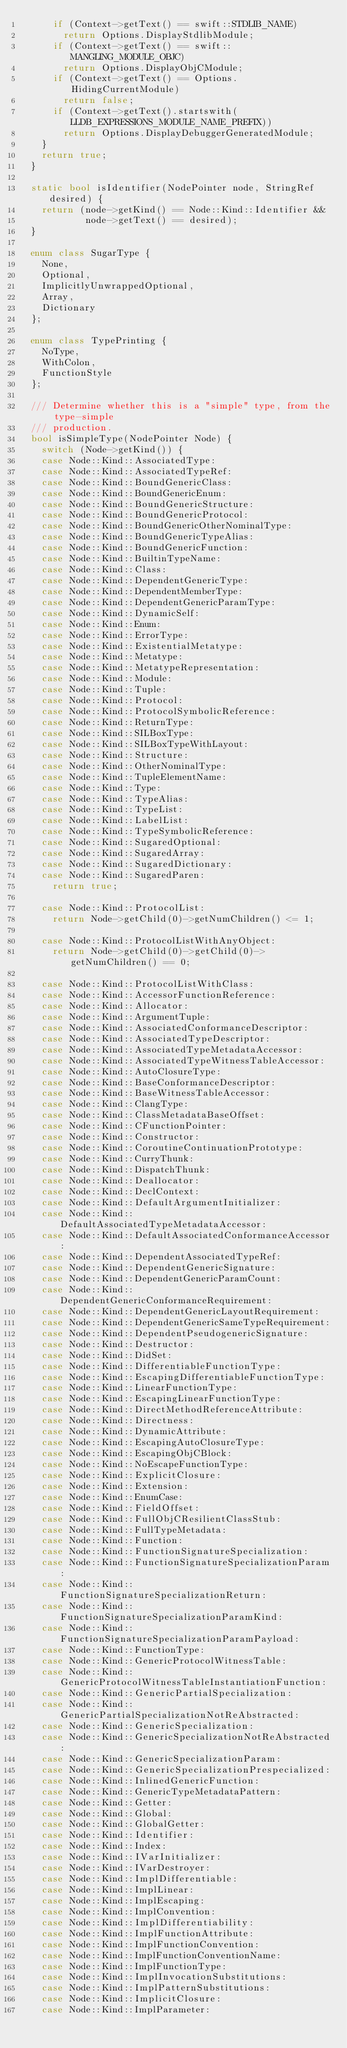Convert code to text. <code><loc_0><loc_0><loc_500><loc_500><_C++_>      if (Context->getText() == swift::STDLIB_NAME)
        return Options.DisplayStdlibModule;
      if (Context->getText() == swift::MANGLING_MODULE_OBJC)
        return Options.DisplayObjCModule;
      if (Context->getText() == Options.HidingCurrentModule)
        return false;
      if (Context->getText().startswith(LLDB_EXPRESSIONS_MODULE_NAME_PREFIX))
        return Options.DisplayDebuggerGeneratedModule;
    }
    return true;
  }

  static bool isIdentifier(NodePointer node, StringRef desired) {
    return (node->getKind() == Node::Kind::Identifier &&
            node->getText() == desired);
  }
  
  enum class SugarType {
    None,
    Optional,
    ImplicitlyUnwrappedOptional,
    Array,
    Dictionary
  };

  enum class TypePrinting {
    NoType,
    WithColon,
    FunctionStyle
  };

  /// Determine whether this is a "simple" type, from the type-simple
  /// production.
  bool isSimpleType(NodePointer Node) {
    switch (Node->getKind()) {
    case Node::Kind::AssociatedType:
    case Node::Kind::AssociatedTypeRef:
    case Node::Kind::BoundGenericClass:
    case Node::Kind::BoundGenericEnum:
    case Node::Kind::BoundGenericStructure:
    case Node::Kind::BoundGenericProtocol:
    case Node::Kind::BoundGenericOtherNominalType:
    case Node::Kind::BoundGenericTypeAlias:
    case Node::Kind::BoundGenericFunction:
    case Node::Kind::BuiltinTypeName:
    case Node::Kind::Class:
    case Node::Kind::DependentGenericType:
    case Node::Kind::DependentMemberType:
    case Node::Kind::DependentGenericParamType:
    case Node::Kind::DynamicSelf:
    case Node::Kind::Enum:
    case Node::Kind::ErrorType:
    case Node::Kind::ExistentialMetatype:
    case Node::Kind::Metatype:
    case Node::Kind::MetatypeRepresentation:
    case Node::Kind::Module:
    case Node::Kind::Tuple:
    case Node::Kind::Protocol:
    case Node::Kind::ProtocolSymbolicReference:
    case Node::Kind::ReturnType:
    case Node::Kind::SILBoxType:
    case Node::Kind::SILBoxTypeWithLayout:
    case Node::Kind::Structure:
    case Node::Kind::OtherNominalType:
    case Node::Kind::TupleElementName:
    case Node::Kind::Type:
    case Node::Kind::TypeAlias:
    case Node::Kind::TypeList:
    case Node::Kind::LabelList:
    case Node::Kind::TypeSymbolicReference:
    case Node::Kind::SugaredOptional:
    case Node::Kind::SugaredArray:
    case Node::Kind::SugaredDictionary:
    case Node::Kind::SugaredParen:
      return true;

    case Node::Kind::ProtocolList:
      return Node->getChild(0)->getNumChildren() <= 1;

    case Node::Kind::ProtocolListWithAnyObject:
      return Node->getChild(0)->getChild(0)->getNumChildren() == 0;

    case Node::Kind::ProtocolListWithClass:
    case Node::Kind::AccessorFunctionReference:
    case Node::Kind::Allocator:
    case Node::Kind::ArgumentTuple:
    case Node::Kind::AssociatedConformanceDescriptor:
    case Node::Kind::AssociatedTypeDescriptor:
    case Node::Kind::AssociatedTypeMetadataAccessor:
    case Node::Kind::AssociatedTypeWitnessTableAccessor:
    case Node::Kind::AutoClosureType:
    case Node::Kind::BaseConformanceDescriptor:
    case Node::Kind::BaseWitnessTableAccessor:
    case Node::Kind::ClangType:
    case Node::Kind::ClassMetadataBaseOffset:
    case Node::Kind::CFunctionPointer:
    case Node::Kind::Constructor:
    case Node::Kind::CoroutineContinuationPrototype:
    case Node::Kind::CurryThunk:
    case Node::Kind::DispatchThunk:
    case Node::Kind::Deallocator:
    case Node::Kind::DeclContext:
    case Node::Kind::DefaultArgumentInitializer:
    case Node::Kind::DefaultAssociatedTypeMetadataAccessor:
    case Node::Kind::DefaultAssociatedConformanceAccessor:
    case Node::Kind::DependentAssociatedTypeRef:
    case Node::Kind::DependentGenericSignature:
    case Node::Kind::DependentGenericParamCount:
    case Node::Kind::DependentGenericConformanceRequirement:
    case Node::Kind::DependentGenericLayoutRequirement:
    case Node::Kind::DependentGenericSameTypeRequirement:
    case Node::Kind::DependentPseudogenericSignature:
    case Node::Kind::Destructor:
    case Node::Kind::DidSet:
    case Node::Kind::DifferentiableFunctionType:
    case Node::Kind::EscapingDifferentiableFunctionType:
    case Node::Kind::LinearFunctionType:
    case Node::Kind::EscapingLinearFunctionType:
    case Node::Kind::DirectMethodReferenceAttribute:
    case Node::Kind::Directness:
    case Node::Kind::DynamicAttribute:
    case Node::Kind::EscapingAutoClosureType:
    case Node::Kind::EscapingObjCBlock:
    case Node::Kind::NoEscapeFunctionType:
    case Node::Kind::ExplicitClosure:
    case Node::Kind::Extension:
    case Node::Kind::EnumCase:
    case Node::Kind::FieldOffset:
    case Node::Kind::FullObjCResilientClassStub:
    case Node::Kind::FullTypeMetadata:
    case Node::Kind::Function:
    case Node::Kind::FunctionSignatureSpecialization:
    case Node::Kind::FunctionSignatureSpecializationParam:
    case Node::Kind::FunctionSignatureSpecializationReturn:
    case Node::Kind::FunctionSignatureSpecializationParamKind:
    case Node::Kind::FunctionSignatureSpecializationParamPayload:
    case Node::Kind::FunctionType:
    case Node::Kind::GenericProtocolWitnessTable:
    case Node::Kind::GenericProtocolWitnessTableInstantiationFunction:
    case Node::Kind::GenericPartialSpecialization:
    case Node::Kind::GenericPartialSpecializationNotReAbstracted:
    case Node::Kind::GenericSpecialization:
    case Node::Kind::GenericSpecializationNotReAbstracted:
    case Node::Kind::GenericSpecializationParam:
    case Node::Kind::GenericSpecializationPrespecialized:
    case Node::Kind::InlinedGenericFunction:
    case Node::Kind::GenericTypeMetadataPattern:
    case Node::Kind::Getter:
    case Node::Kind::Global:
    case Node::Kind::GlobalGetter:
    case Node::Kind::Identifier:
    case Node::Kind::Index:
    case Node::Kind::IVarInitializer:
    case Node::Kind::IVarDestroyer:
    case Node::Kind::ImplDifferentiable:
    case Node::Kind::ImplLinear:
    case Node::Kind::ImplEscaping:
    case Node::Kind::ImplConvention:
    case Node::Kind::ImplDifferentiability:
    case Node::Kind::ImplFunctionAttribute:
    case Node::Kind::ImplFunctionConvention:
    case Node::Kind::ImplFunctionConventionName:
    case Node::Kind::ImplFunctionType:
    case Node::Kind::ImplInvocationSubstitutions:
    case Node::Kind::ImplPatternSubstitutions:
    case Node::Kind::ImplicitClosure:
    case Node::Kind::ImplParameter:</code> 